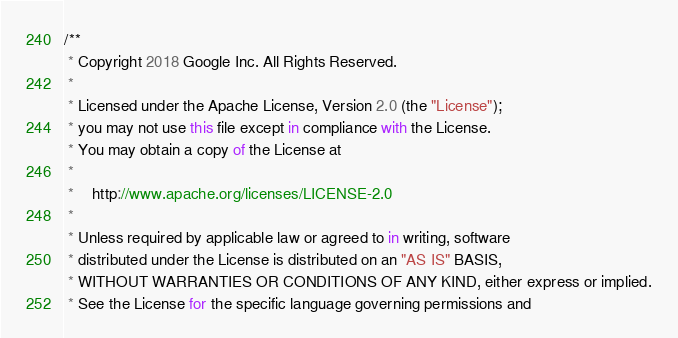<code> <loc_0><loc_0><loc_500><loc_500><_TypeScript_>/**
 * Copyright 2018 Google Inc. All Rights Reserved.
 *
 * Licensed under the Apache License, Version 2.0 (the "License");
 * you may not use this file except in compliance with the License.
 * You may obtain a copy of the License at
 *
 *    http://www.apache.org/licenses/LICENSE-2.0
 *
 * Unless required by applicable law or agreed to in writing, software
 * distributed under the License is distributed on an "AS IS" BASIS,
 * WITHOUT WARRANTIES OR CONDITIONS OF ANY KIND, either express or implied.
 * See the License for the specific language governing permissions and</code> 